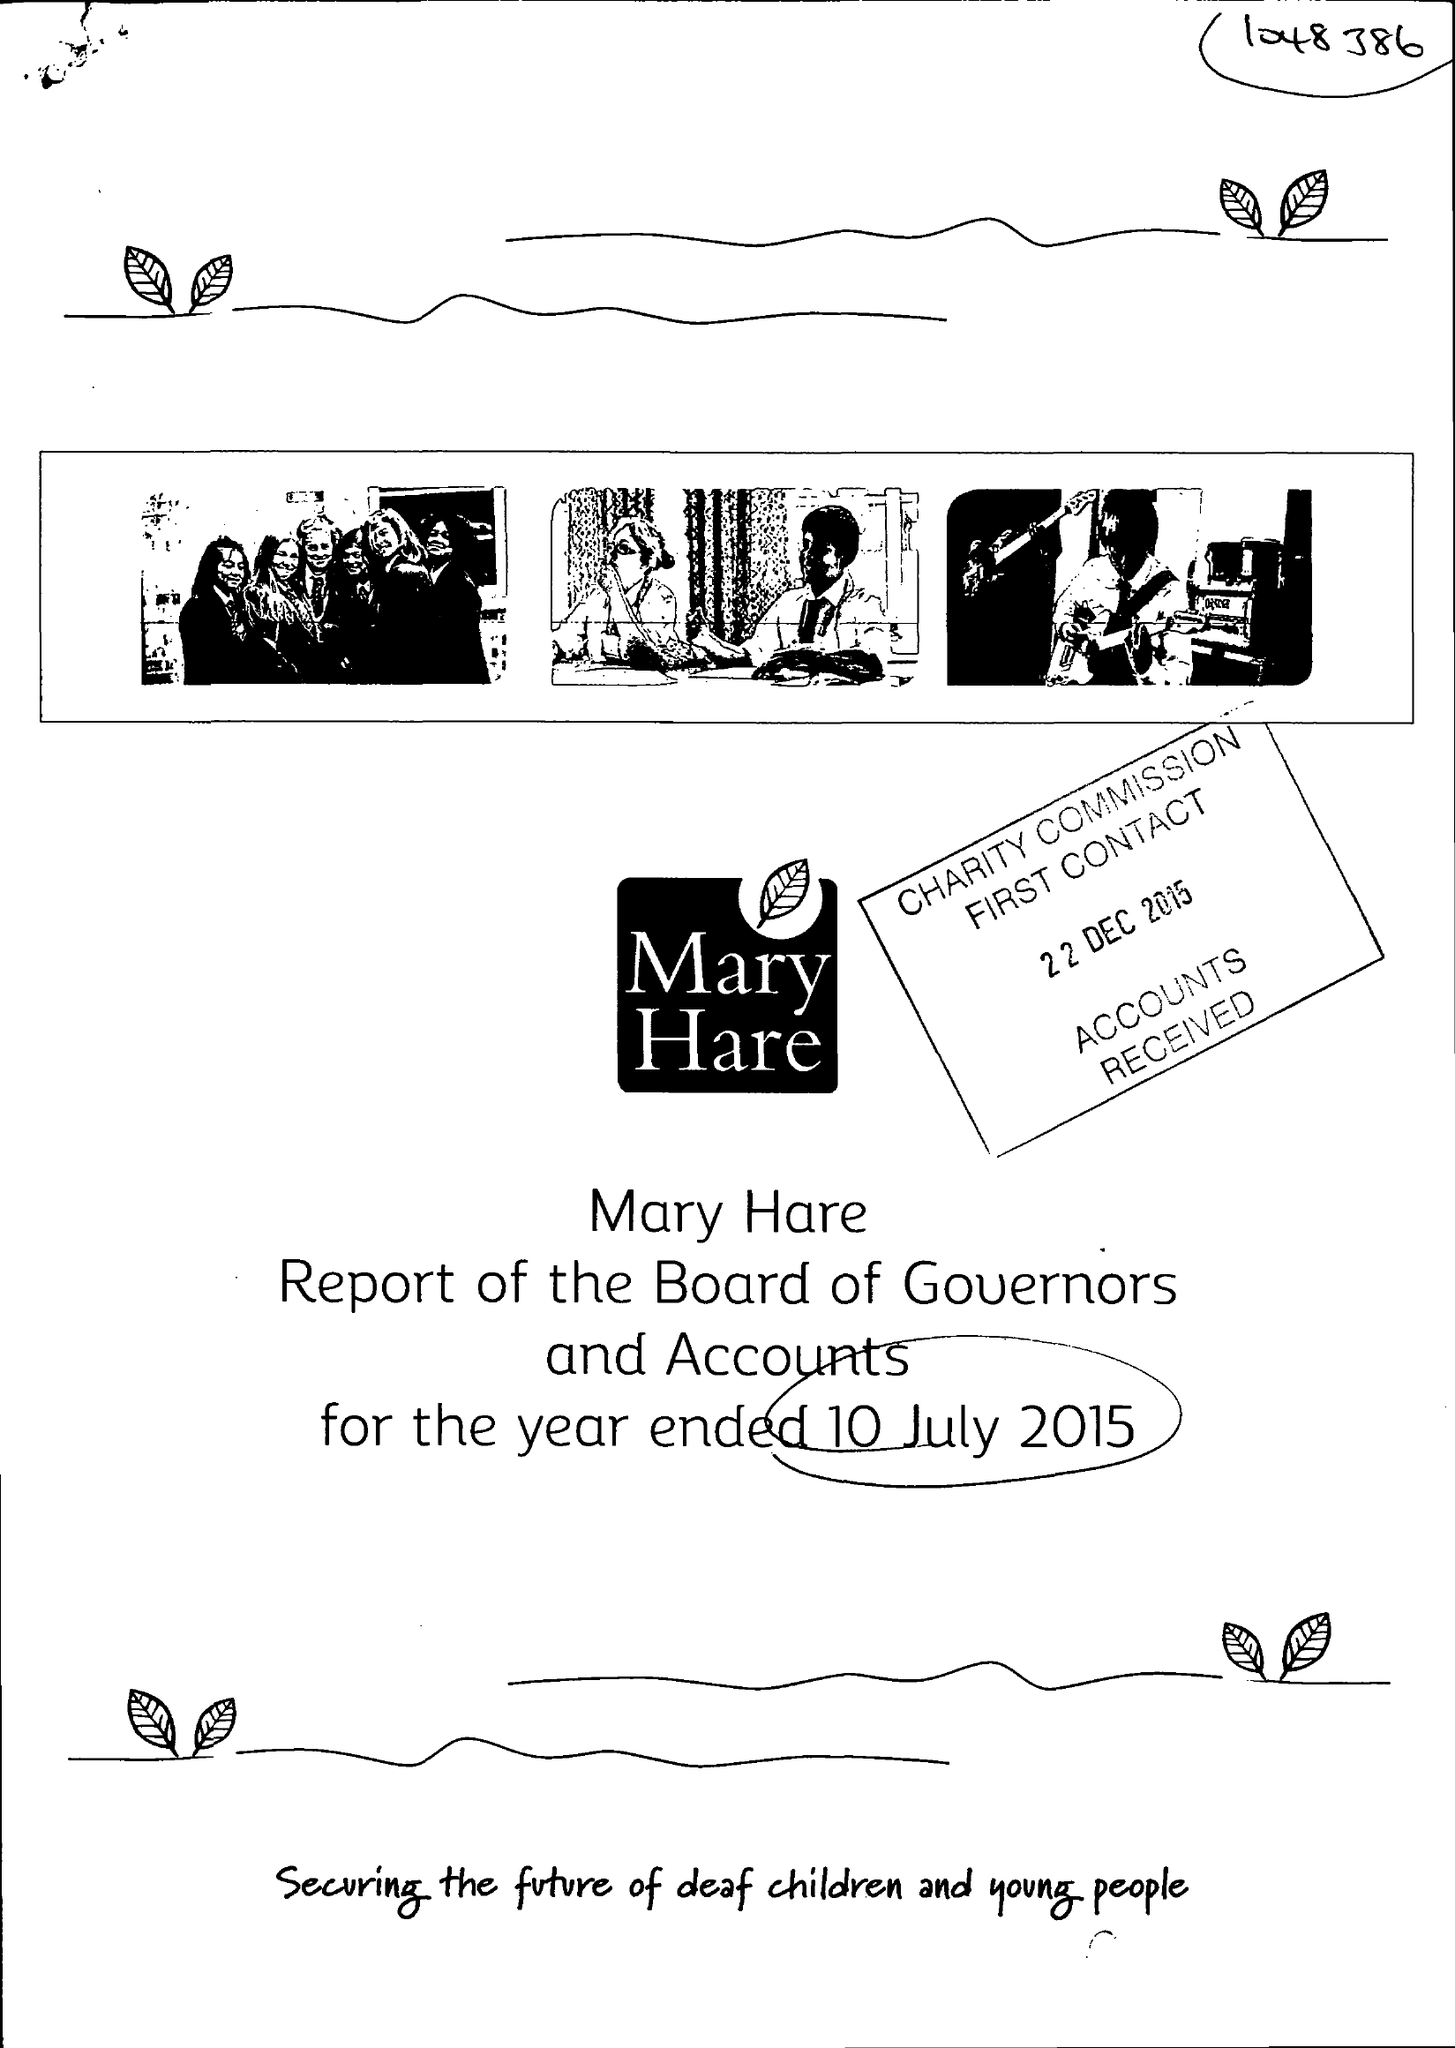What is the value for the spending_annually_in_british_pounds?
Answer the question using a single word or phrase. 10878000.00 